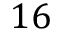Convert formula to latex. <formula><loc_0><loc_0><loc_500><loc_500>1 6</formula> 